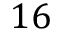Convert formula to latex. <formula><loc_0><loc_0><loc_500><loc_500>1 6</formula> 